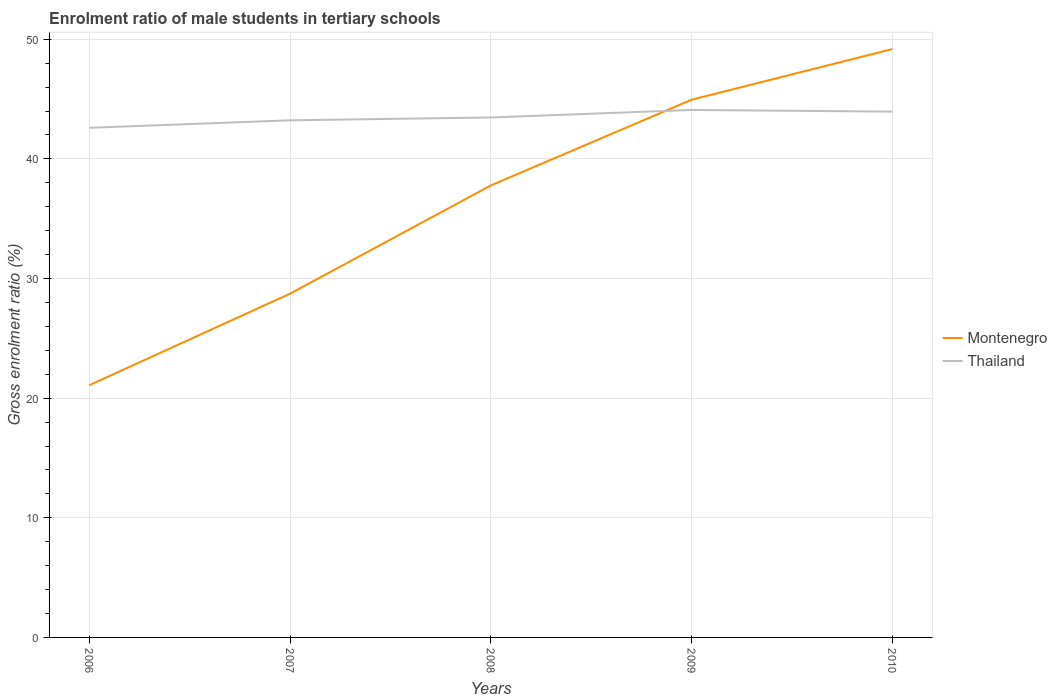Is the number of lines equal to the number of legend labels?
Give a very brief answer. Yes. Across all years, what is the maximum enrolment ratio of male students in tertiary schools in Thailand?
Provide a short and direct response. 42.6. What is the total enrolment ratio of male students in tertiary schools in Montenegro in the graph?
Keep it short and to the point. -7.17. What is the difference between the highest and the second highest enrolment ratio of male students in tertiary schools in Thailand?
Offer a terse response. 1.49. What is the difference between the highest and the lowest enrolment ratio of male students in tertiary schools in Thailand?
Make the answer very short. 2. How many lines are there?
Your answer should be compact. 2. Does the graph contain any zero values?
Provide a succinct answer. No. Does the graph contain grids?
Ensure brevity in your answer.  Yes. How are the legend labels stacked?
Make the answer very short. Vertical. What is the title of the graph?
Ensure brevity in your answer.  Enrolment ratio of male students in tertiary schools. What is the label or title of the Y-axis?
Ensure brevity in your answer.  Gross enrolment ratio (%). What is the Gross enrolment ratio (%) in Montenegro in 2006?
Provide a short and direct response. 21.08. What is the Gross enrolment ratio (%) in Thailand in 2006?
Ensure brevity in your answer.  42.6. What is the Gross enrolment ratio (%) of Montenegro in 2007?
Make the answer very short. 28.74. What is the Gross enrolment ratio (%) in Thailand in 2007?
Offer a very short reply. 43.23. What is the Gross enrolment ratio (%) of Montenegro in 2008?
Offer a very short reply. 37.78. What is the Gross enrolment ratio (%) of Thailand in 2008?
Ensure brevity in your answer.  43.47. What is the Gross enrolment ratio (%) of Montenegro in 2009?
Offer a very short reply. 44.95. What is the Gross enrolment ratio (%) in Thailand in 2009?
Provide a succinct answer. 44.09. What is the Gross enrolment ratio (%) in Montenegro in 2010?
Your response must be concise. 49.18. What is the Gross enrolment ratio (%) in Thailand in 2010?
Provide a succinct answer. 43.95. Across all years, what is the maximum Gross enrolment ratio (%) of Montenegro?
Provide a succinct answer. 49.18. Across all years, what is the maximum Gross enrolment ratio (%) in Thailand?
Offer a terse response. 44.09. Across all years, what is the minimum Gross enrolment ratio (%) in Montenegro?
Offer a very short reply. 21.08. Across all years, what is the minimum Gross enrolment ratio (%) in Thailand?
Your answer should be very brief. 42.6. What is the total Gross enrolment ratio (%) in Montenegro in the graph?
Your answer should be very brief. 181.74. What is the total Gross enrolment ratio (%) in Thailand in the graph?
Keep it short and to the point. 217.34. What is the difference between the Gross enrolment ratio (%) of Montenegro in 2006 and that in 2007?
Provide a succinct answer. -7.65. What is the difference between the Gross enrolment ratio (%) of Thailand in 2006 and that in 2007?
Make the answer very short. -0.63. What is the difference between the Gross enrolment ratio (%) of Montenegro in 2006 and that in 2008?
Make the answer very short. -16.7. What is the difference between the Gross enrolment ratio (%) in Thailand in 2006 and that in 2008?
Make the answer very short. -0.86. What is the difference between the Gross enrolment ratio (%) in Montenegro in 2006 and that in 2009?
Provide a short and direct response. -23.87. What is the difference between the Gross enrolment ratio (%) in Thailand in 2006 and that in 2009?
Offer a terse response. -1.49. What is the difference between the Gross enrolment ratio (%) of Montenegro in 2006 and that in 2010?
Offer a terse response. -28.1. What is the difference between the Gross enrolment ratio (%) in Thailand in 2006 and that in 2010?
Keep it short and to the point. -1.35. What is the difference between the Gross enrolment ratio (%) of Montenegro in 2007 and that in 2008?
Your response must be concise. -9.05. What is the difference between the Gross enrolment ratio (%) in Thailand in 2007 and that in 2008?
Ensure brevity in your answer.  -0.24. What is the difference between the Gross enrolment ratio (%) of Montenegro in 2007 and that in 2009?
Your answer should be very brief. -16.22. What is the difference between the Gross enrolment ratio (%) of Thailand in 2007 and that in 2009?
Provide a succinct answer. -0.87. What is the difference between the Gross enrolment ratio (%) of Montenegro in 2007 and that in 2010?
Your answer should be compact. -20.45. What is the difference between the Gross enrolment ratio (%) of Thailand in 2007 and that in 2010?
Ensure brevity in your answer.  -0.73. What is the difference between the Gross enrolment ratio (%) of Montenegro in 2008 and that in 2009?
Offer a very short reply. -7.17. What is the difference between the Gross enrolment ratio (%) in Thailand in 2008 and that in 2009?
Make the answer very short. -0.63. What is the difference between the Gross enrolment ratio (%) in Montenegro in 2008 and that in 2010?
Your answer should be compact. -11.4. What is the difference between the Gross enrolment ratio (%) in Thailand in 2008 and that in 2010?
Provide a succinct answer. -0.49. What is the difference between the Gross enrolment ratio (%) of Montenegro in 2009 and that in 2010?
Make the answer very short. -4.23. What is the difference between the Gross enrolment ratio (%) of Thailand in 2009 and that in 2010?
Your answer should be compact. 0.14. What is the difference between the Gross enrolment ratio (%) of Montenegro in 2006 and the Gross enrolment ratio (%) of Thailand in 2007?
Offer a very short reply. -22.14. What is the difference between the Gross enrolment ratio (%) in Montenegro in 2006 and the Gross enrolment ratio (%) in Thailand in 2008?
Offer a very short reply. -22.38. What is the difference between the Gross enrolment ratio (%) of Montenegro in 2006 and the Gross enrolment ratio (%) of Thailand in 2009?
Provide a short and direct response. -23.01. What is the difference between the Gross enrolment ratio (%) of Montenegro in 2006 and the Gross enrolment ratio (%) of Thailand in 2010?
Make the answer very short. -22.87. What is the difference between the Gross enrolment ratio (%) in Montenegro in 2007 and the Gross enrolment ratio (%) in Thailand in 2008?
Give a very brief answer. -14.73. What is the difference between the Gross enrolment ratio (%) of Montenegro in 2007 and the Gross enrolment ratio (%) of Thailand in 2009?
Your answer should be very brief. -15.36. What is the difference between the Gross enrolment ratio (%) in Montenegro in 2007 and the Gross enrolment ratio (%) in Thailand in 2010?
Your response must be concise. -15.22. What is the difference between the Gross enrolment ratio (%) of Montenegro in 2008 and the Gross enrolment ratio (%) of Thailand in 2009?
Ensure brevity in your answer.  -6.31. What is the difference between the Gross enrolment ratio (%) in Montenegro in 2008 and the Gross enrolment ratio (%) in Thailand in 2010?
Make the answer very short. -6.17. What is the difference between the Gross enrolment ratio (%) in Montenegro in 2009 and the Gross enrolment ratio (%) in Thailand in 2010?
Provide a short and direct response. 1. What is the average Gross enrolment ratio (%) of Montenegro per year?
Your response must be concise. 36.35. What is the average Gross enrolment ratio (%) of Thailand per year?
Make the answer very short. 43.47. In the year 2006, what is the difference between the Gross enrolment ratio (%) in Montenegro and Gross enrolment ratio (%) in Thailand?
Your answer should be very brief. -21.52. In the year 2007, what is the difference between the Gross enrolment ratio (%) of Montenegro and Gross enrolment ratio (%) of Thailand?
Your response must be concise. -14.49. In the year 2008, what is the difference between the Gross enrolment ratio (%) of Montenegro and Gross enrolment ratio (%) of Thailand?
Give a very brief answer. -5.68. In the year 2009, what is the difference between the Gross enrolment ratio (%) of Montenegro and Gross enrolment ratio (%) of Thailand?
Your response must be concise. 0.86. In the year 2010, what is the difference between the Gross enrolment ratio (%) of Montenegro and Gross enrolment ratio (%) of Thailand?
Your answer should be very brief. 5.23. What is the ratio of the Gross enrolment ratio (%) in Montenegro in 2006 to that in 2007?
Your answer should be compact. 0.73. What is the ratio of the Gross enrolment ratio (%) in Thailand in 2006 to that in 2007?
Your answer should be compact. 0.99. What is the ratio of the Gross enrolment ratio (%) of Montenegro in 2006 to that in 2008?
Provide a succinct answer. 0.56. What is the ratio of the Gross enrolment ratio (%) in Thailand in 2006 to that in 2008?
Give a very brief answer. 0.98. What is the ratio of the Gross enrolment ratio (%) in Montenegro in 2006 to that in 2009?
Make the answer very short. 0.47. What is the ratio of the Gross enrolment ratio (%) of Thailand in 2006 to that in 2009?
Give a very brief answer. 0.97. What is the ratio of the Gross enrolment ratio (%) in Montenegro in 2006 to that in 2010?
Your answer should be compact. 0.43. What is the ratio of the Gross enrolment ratio (%) in Thailand in 2006 to that in 2010?
Ensure brevity in your answer.  0.97. What is the ratio of the Gross enrolment ratio (%) in Montenegro in 2007 to that in 2008?
Keep it short and to the point. 0.76. What is the ratio of the Gross enrolment ratio (%) in Thailand in 2007 to that in 2008?
Provide a short and direct response. 0.99. What is the ratio of the Gross enrolment ratio (%) of Montenegro in 2007 to that in 2009?
Provide a succinct answer. 0.64. What is the ratio of the Gross enrolment ratio (%) of Thailand in 2007 to that in 2009?
Provide a succinct answer. 0.98. What is the ratio of the Gross enrolment ratio (%) of Montenegro in 2007 to that in 2010?
Your answer should be very brief. 0.58. What is the ratio of the Gross enrolment ratio (%) in Thailand in 2007 to that in 2010?
Your answer should be very brief. 0.98. What is the ratio of the Gross enrolment ratio (%) in Montenegro in 2008 to that in 2009?
Provide a succinct answer. 0.84. What is the ratio of the Gross enrolment ratio (%) in Thailand in 2008 to that in 2009?
Provide a succinct answer. 0.99. What is the ratio of the Gross enrolment ratio (%) of Montenegro in 2008 to that in 2010?
Ensure brevity in your answer.  0.77. What is the ratio of the Gross enrolment ratio (%) in Thailand in 2008 to that in 2010?
Ensure brevity in your answer.  0.99. What is the ratio of the Gross enrolment ratio (%) of Montenegro in 2009 to that in 2010?
Provide a succinct answer. 0.91. What is the ratio of the Gross enrolment ratio (%) in Thailand in 2009 to that in 2010?
Your answer should be very brief. 1. What is the difference between the highest and the second highest Gross enrolment ratio (%) in Montenegro?
Provide a short and direct response. 4.23. What is the difference between the highest and the second highest Gross enrolment ratio (%) in Thailand?
Provide a succinct answer. 0.14. What is the difference between the highest and the lowest Gross enrolment ratio (%) in Montenegro?
Offer a terse response. 28.1. What is the difference between the highest and the lowest Gross enrolment ratio (%) of Thailand?
Your response must be concise. 1.49. 